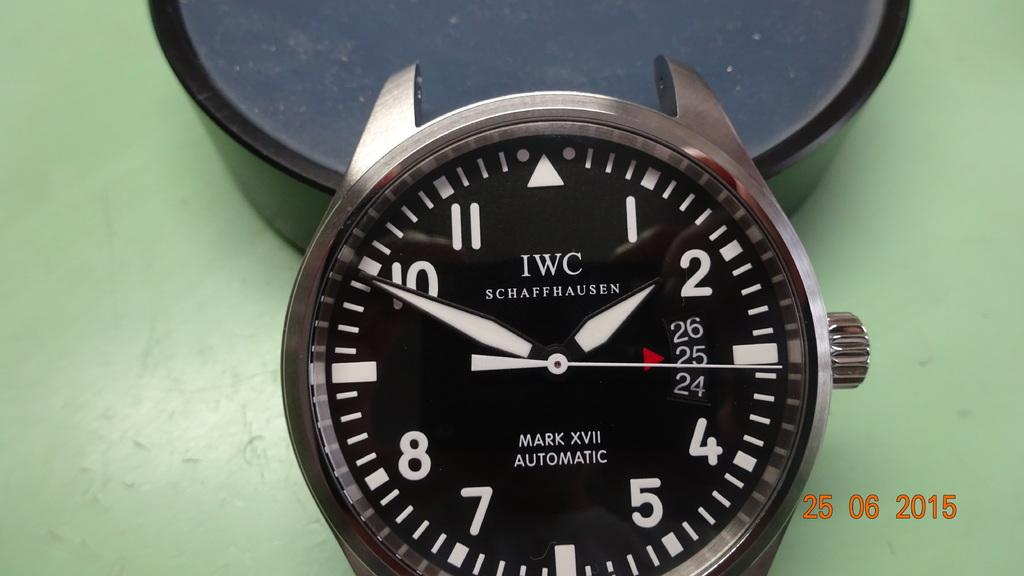<image>
Give a short and clear explanation of the subsequent image. An IWC watch sits on top of a green table with the hands pointing to 2 and 10 